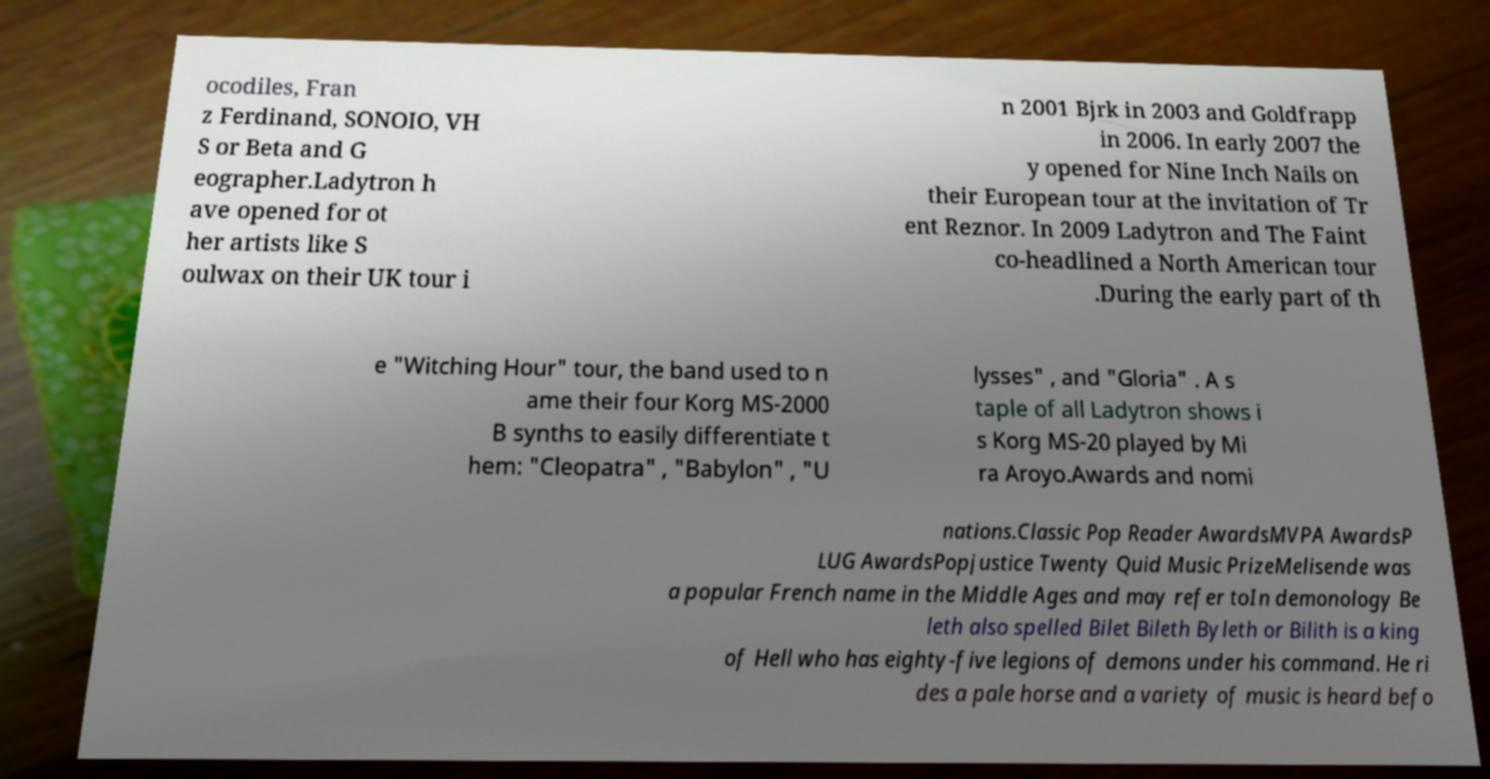There's text embedded in this image that I need extracted. Can you transcribe it verbatim? ocodiles, Fran z Ferdinand, SONOIO, VH S or Beta and G eographer.Ladytron h ave opened for ot her artists like S oulwax on their UK tour i n 2001 Bjrk in 2003 and Goldfrapp in 2006. In early 2007 the y opened for Nine Inch Nails on their European tour at the invitation of Tr ent Reznor. In 2009 Ladytron and The Faint co-headlined a North American tour .During the early part of th e "Witching Hour" tour, the band used to n ame their four Korg MS-2000 B synths to easily differentiate t hem: "Cleopatra" , "Babylon" , "U lysses" , and "Gloria" . A s taple of all Ladytron shows i s Korg MS-20 played by Mi ra Aroyo.Awards and nomi nations.Classic Pop Reader AwardsMVPA AwardsP LUG AwardsPopjustice Twenty Quid Music PrizeMelisende was a popular French name in the Middle Ages and may refer toIn demonology Be leth also spelled Bilet Bileth Byleth or Bilith is a king of Hell who has eighty-five legions of demons under his command. He ri des a pale horse and a variety of music is heard befo 